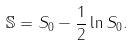<formula> <loc_0><loc_0><loc_500><loc_500>\mathbb { S } = S _ { 0 } - \frac { 1 } { 2 } \ln S _ { 0 } .</formula> 